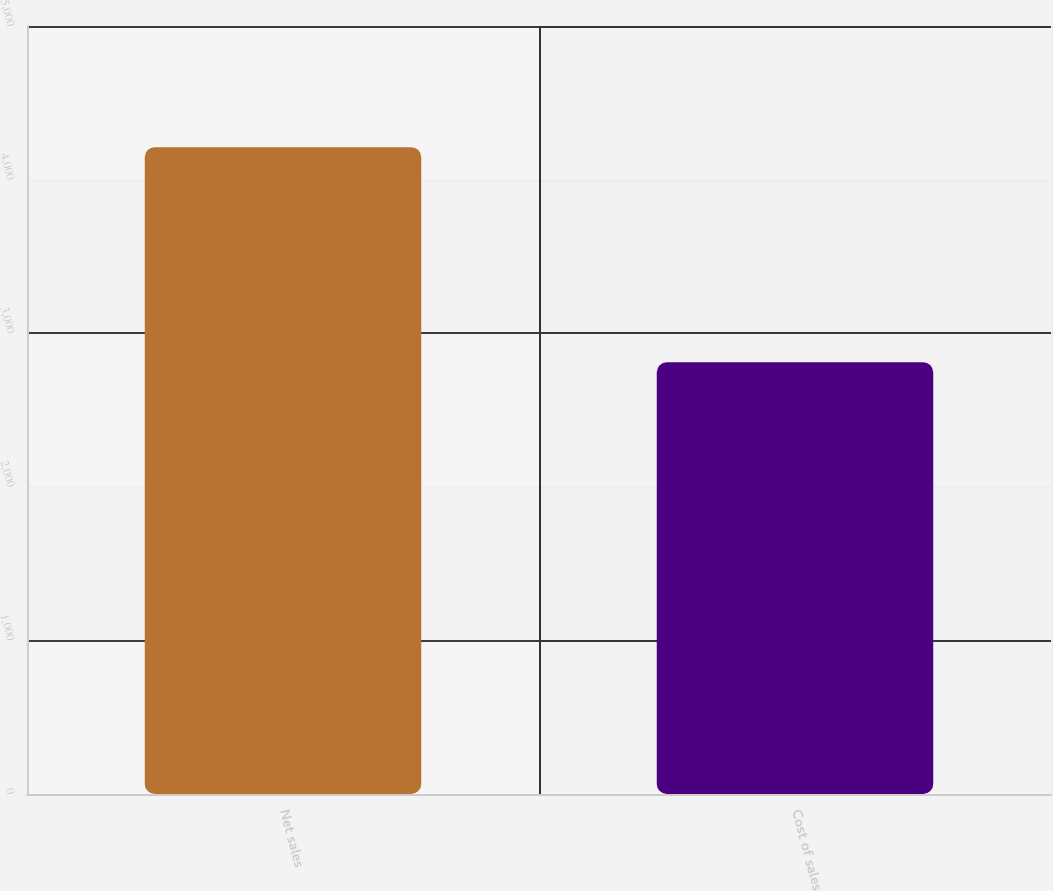Convert chart. <chart><loc_0><loc_0><loc_500><loc_500><bar_chart><fcel>Net sales<fcel>Cost of sales<nl><fcel>4211.3<fcel>2810.3<nl></chart> 